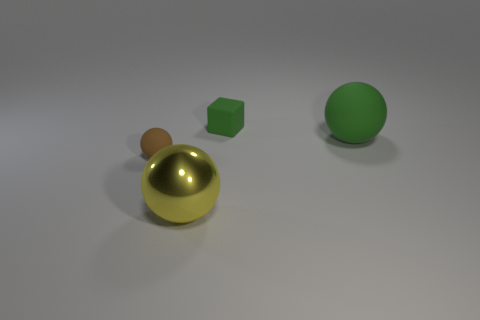Subtract all green rubber balls. How many balls are left? 2 Add 4 large metallic objects. How many objects exist? 8 Subtract 1 cubes. How many cubes are left? 0 Subtract all balls. How many objects are left? 1 Subtract all green matte balls. Subtract all metal spheres. How many objects are left? 2 Add 1 tiny brown rubber balls. How many tiny brown rubber balls are left? 2 Add 2 big yellow shiny objects. How many big yellow shiny objects exist? 3 Subtract 0 purple cubes. How many objects are left? 4 Subtract all yellow blocks. Subtract all purple cylinders. How many blocks are left? 1 